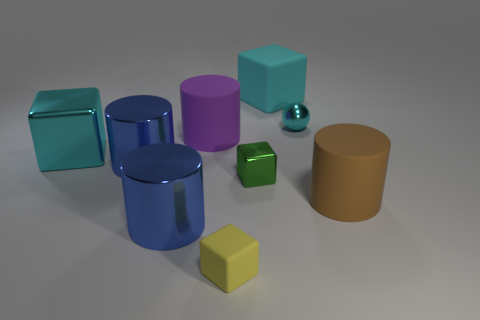Can you describe the arrangement of shapes in terms of their colors and relative positions? Certainly! In the image, we observe a variety of geometric shapes with different colors. On the left, there are two cubes, one teal and one blue, with the teal cube positioned in front of the blue one. Closer to the center, there's a large blue cylinder, behind which stands a purple cylinder and an orange cylinder to its right. In the forefront, there's a small green cube, and beside it, to the right, there is a small yellow cube. Finally, there's a shiny, reflective ball that seems slightly distanced from the other objects, close to the purple cylinder. 